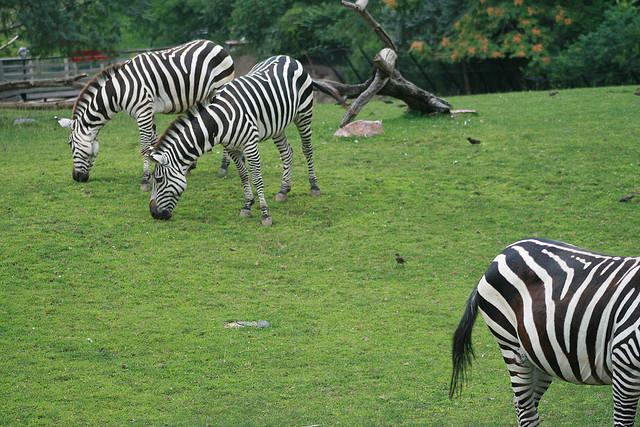Are the zebras fighting?
Be succinct. No. How many zebras can you see eating?
Quick response, please. 2. Is there a fence in the background?
Write a very short answer. Yes. 